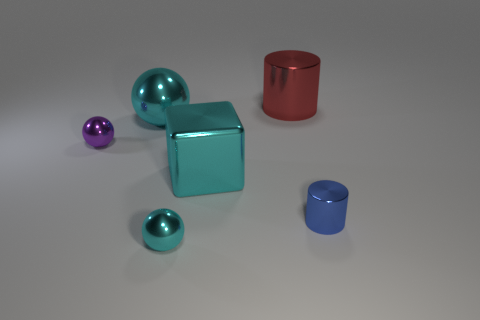Subtract 1 cubes. How many cubes are left? 0 Add 1 large red cylinders. How many objects exist? 7 Subtract 0 brown spheres. How many objects are left? 6 Subtract all cylinders. How many objects are left? 4 Subtract all red cylinders. Subtract all blue cubes. How many cylinders are left? 1 Subtract all purple spheres. How many red cubes are left? 0 Subtract all big gray matte cylinders. Subtract all red metallic cylinders. How many objects are left? 5 Add 3 big metallic cylinders. How many big metallic cylinders are left? 4 Add 4 big yellow cylinders. How many big yellow cylinders exist? 4 Subtract all purple balls. How many balls are left? 2 